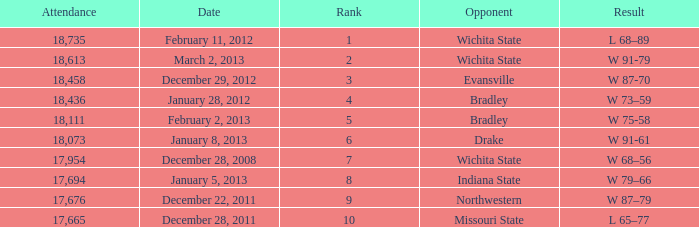What's the rank for February 11, 2012 with less than 18,735 in attendance? None. 